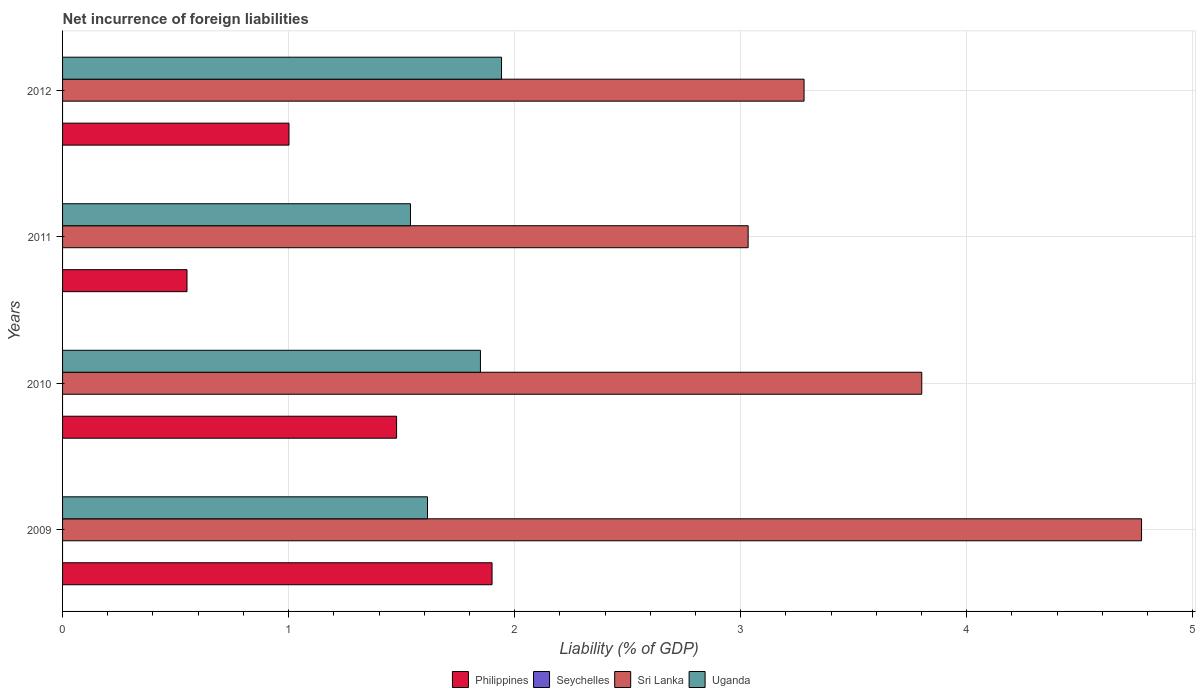How many groups of bars are there?
Offer a terse response. 4. Are the number of bars on each tick of the Y-axis equal?
Give a very brief answer. Yes. How many bars are there on the 4th tick from the top?
Provide a succinct answer. 3. How many bars are there on the 3rd tick from the bottom?
Give a very brief answer. 3. What is the net incurrence of foreign liabilities in Sri Lanka in 2009?
Your answer should be very brief. 4.77. Across all years, what is the maximum net incurrence of foreign liabilities in Philippines?
Provide a succinct answer. 1.9. In which year was the net incurrence of foreign liabilities in Uganda maximum?
Make the answer very short. 2012. What is the total net incurrence of foreign liabilities in Seychelles in the graph?
Your response must be concise. 0. What is the difference between the net incurrence of foreign liabilities in Philippines in 2009 and that in 2010?
Keep it short and to the point. 0.42. What is the difference between the net incurrence of foreign liabilities in Uganda in 2010 and the net incurrence of foreign liabilities in Seychelles in 2012?
Provide a succinct answer. 1.85. What is the average net incurrence of foreign liabilities in Philippines per year?
Make the answer very short. 1.23. In the year 2011, what is the difference between the net incurrence of foreign liabilities in Uganda and net incurrence of foreign liabilities in Philippines?
Offer a terse response. 0.99. What is the ratio of the net incurrence of foreign liabilities in Sri Lanka in 2009 to that in 2011?
Ensure brevity in your answer.  1.57. What is the difference between the highest and the second highest net incurrence of foreign liabilities in Philippines?
Your response must be concise. 0.42. What is the difference between the highest and the lowest net incurrence of foreign liabilities in Uganda?
Your response must be concise. 0.4. Is it the case that in every year, the sum of the net incurrence of foreign liabilities in Philippines and net incurrence of foreign liabilities in Uganda is greater than the sum of net incurrence of foreign liabilities in Seychelles and net incurrence of foreign liabilities in Sri Lanka?
Your answer should be compact. No. Are all the bars in the graph horizontal?
Provide a short and direct response. Yes. How many years are there in the graph?
Ensure brevity in your answer.  4. What is the difference between two consecutive major ticks on the X-axis?
Your answer should be very brief. 1. Does the graph contain grids?
Your answer should be compact. Yes. Where does the legend appear in the graph?
Provide a succinct answer. Bottom center. What is the title of the graph?
Your answer should be very brief. Net incurrence of foreign liabilities. What is the label or title of the X-axis?
Offer a terse response. Liability (% of GDP). What is the Liability (% of GDP) in Philippines in 2009?
Provide a succinct answer. 1.9. What is the Liability (% of GDP) of Sri Lanka in 2009?
Offer a very short reply. 4.77. What is the Liability (% of GDP) in Uganda in 2009?
Offer a very short reply. 1.61. What is the Liability (% of GDP) of Philippines in 2010?
Provide a short and direct response. 1.48. What is the Liability (% of GDP) of Sri Lanka in 2010?
Your answer should be very brief. 3.8. What is the Liability (% of GDP) in Uganda in 2010?
Offer a terse response. 1.85. What is the Liability (% of GDP) of Philippines in 2011?
Offer a very short reply. 0.55. What is the Liability (% of GDP) of Seychelles in 2011?
Offer a very short reply. 0. What is the Liability (% of GDP) of Sri Lanka in 2011?
Provide a succinct answer. 3.03. What is the Liability (% of GDP) in Uganda in 2011?
Provide a succinct answer. 1.54. What is the Liability (% of GDP) in Philippines in 2012?
Provide a succinct answer. 1. What is the Liability (% of GDP) of Sri Lanka in 2012?
Give a very brief answer. 3.28. What is the Liability (% of GDP) of Uganda in 2012?
Your answer should be compact. 1.94. Across all years, what is the maximum Liability (% of GDP) in Philippines?
Provide a short and direct response. 1.9. Across all years, what is the maximum Liability (% of GDP) in Sri Lanka?
Your answer should be very brief. 4.77. Across all years, what is the maximum Liability (% of GDP) in Uganda?
Provide a short and direct response. 1.94. Across all years, what is the minimum Liability (% of GDP) in Philippines?
Offer a terse response. 0.55. Across all years, what is the minimum Liability (% of GDP) of Sri Lanka?
Ensure brevity in your answer.  3.03. Across all years, what is the minimum Liability (% of GDP) of Uganda?
Ensure brevity in your answer.  1.54. What is the total Liability (% of GDP) of Philippines in the graph?
Your response must be concise. 4.93. What is the total Liability (% of GDP) of Seychelles in the graph?
Make the answer very short. 0. What is the total Liability (% of GDP) in Sri Lanka in the graph?
Your response must be concise. 14.89. What is the total Liability (% of GDP) in Uganda in the graph?
Provide a short and direct response. 6.94. What is the difference between the Liability (% of GDP) in Philippines in 2009 and that in 2010?
Offer a terse response. 0.42. What is the difference between the Liability (% of GDP) in Sri Lanka in 2009 and that in 2010?
Your answer should be very brief. 0.97. What is the difference between the Liability (% of GDP) in Uganda in 2009 and that in 2010?
Provide a succinct answer. -0.23. What is the difference between the Liability (% of GDP) in Philippines in 2009 and that in 2011?
Provide a short and direct response. 1.35. What is the difference between the Liability (% of GDP) of Sri Lanka in 2009 and that in 2011?
Your response must be concise. 1.74. What is the difference between the Liability (% of GDP) in Uganda in 2009 and that in 2011?
Provide a short and direct response. 0.08. What is the difference between the Liability (% of GDP) in Philippines in 2009 and that in 2012?
Ensure brevity in your answer.  0.9. What is the difference between the Liability (% of GDP) of Sri Lanka in 2009 and that in 2012?
Offer a terse response. 1.49. What is the difference between the Liability (% of GDP) in Uganda in 2009 and that in 2012?
Your response must be concise. -0.33. What is the difference between the Liability (% of GDP) in Philippines in 2010 and that in 2011?
Provide a succinct answer. 0.93. What is the difference between the Liability (% of GDP) of Sri Lanka in 2010 and that in 2011?
Provide a short and direct response. 0.77. What is the difference between the Liability (% of GDP) in Uganda in 2010 and that in 2011?
Your answer should be compact. 0.31. What is the difference between the Liability (% of GDP) in Philippines in 2010 and that in 2012?
Keep it short and to the point. 0.48. What is the difference between the Liability (% of GDP) in Sri Lanka in 2010 and that in 2012?
Your answer should be very brief. 0.52. What is the difference between the Liability (% of GDP) of Uganda in 2010 and that in 2012?
Keep it short and to the point. -0.09. What is the difference between the Liability (% of GDP) in Philippines in 2011 and that in 2012?
Make the answer very short. -0.45. What is the difference between the Liability (% of GDP) in Sri Lanka in 2011 and that in 2012?
Offer a terse response. -0.25. What is the difference between the Liability (% of GDP) in Uganda in 2011 and that in 2012?
Keep it short and to the point. -0.4. What is the difference between the Liability (% of GDP) in Philippines in 2009 and the Liability (% of GDP) in Sri Lanka in 2010?
Offer a very short reply. -1.9. What is the difference between the Liability (% of GDP) in Philippines in 2009 and the Liability (% of GDP) in Uganda in 2010?
Offer a terse response. 0.05. What is the difference between the Liability (% of GDP) in Sri Lanka in 2009 and the Liability (% of GDP) in Uganda in 2010?
Offer a very short reply. 2.92. What is the difference between the Liability (% of GDP) of Philippines in 2009 and the Liability (% of GDP) of Sri Lanka in 2011?
Your response must be concise. -1.13. What is the difference between the Liability (% of GDP) in Philippines in 2009 and the Liability (% of GDP) in Uganda in 2011?
Keep it short and to the point. 0.36. What is the difference between the Liability (% of GDP) in Sri Lanka in 2009 and the Liability (% of GDP) in Uganda in 2011?
Make the answer very short. 3.23. What is the difference between the Liability (% of GDP) of Philippines in 2009 and the Liability (% of GDP) of Sri Lanka in 2012?
Offer a terse response. -1.38. What is the difference between the Liability (% of GDP) of Philippines in 2009 and the Liability (% of GDP) of Uganda in 2012?
Offer a terse response. -0.04. What is the difference between the Liability (% of GDP) of Sri Lanka in 2009 and the Liability (% of GDP) of Uganda in 2012?
Give a very brief answer. 2.83. What is the difference between the Liability (% of GDP) in Philippines in 2010 and the Liability (% of GDP) in Sri Lanka in 2011?
Your answer should be very brief. -1.56. What is the difference between the Liability (% of GDP) in Philippines in 2010 and the Liability (% of GDP) in Uganda in 2011?
Your answer should be compact. -0.06. What is the difference between the Liability (% of GDP) of Sri Lanka in 2010 and the Liability (% of GDP) of Uganda in 2011?
Your answer should be compact. 2.26. What is the difference between the Liability (% of GDP) in Philippines in 2010 and the Liability (% of GDP) in Sri Lanka in 2012?
Ensure brevity in your answer.  -1.8. What is the difference between the Liability (% of GDP) in Philippines in 2010 and the Liability (% of GDP) in Uganda in 2012?
Provide a succinct answer. -0.46. What is the difference between the Liability (% of GDP) of Sri Lanka in 2010 and the Liability (% of GDP) of Uganda in 2012?
Provide a succinct answer. 1.86. What is the difference between the Liability (% of GDP) of Philippines in 2011 and the Liability (% of GDP) of Sri Lanka in 2012?
Your answer should be compact. -2.73. What is the difference between the Liability (% of GDP) in Philippines in 2011 and the Liability (% of GDP) in Uganda in 2012?
Give a very brief answer. -1.39. What is the difference between the Liability (% of GDP) in Sri Lanka in 2011 and the Liability (% of GDP) in Uganda in 2012?
Your answer should be compact. 1.09. What is the average Liability (% of GDP) of Philippines per year?
Give a very brief answer. 1.23. What is the average Liability (% of GDP) in Seychelles per year?
Offer a very short reply. 0. What is the average Liability (% of GDP) of Sri Lanka per year?
Make the answer very short. 3.72. What is the average Liability (% of GDP) in Uganda per year?
Keep it short and to the point. 1.74. In the year 2009, what is the difference between the Liability (% of GDP) in Philippines and Liability (% of GDP) in Sri Lanka?
Your response must be concise. -2.87. In the year 2009, what is the difference between the Liability (% of GDP) in Philippines and Liability (% of GDP) in Uganda?
Keep it short and to the point. 0.29. In the year 2009, what is the difference between the Liability (% of GDP) in Sri Lanka and Liability (% of GDP) in Uganda?
Provide a succinct answer. 3.16. In the year 2010, what is the difference between the Liability (% of GDP) of Philippines and Liability (% of GDP) of Sri Lanka?
Offer a terse response. -2.32. In the year 2010, what is the difference between the Liability (% of GDP) of Philippines and Liability (% of GDP) of Uganda?
Provide a succinct answer. -0.37. In the year 2010, what is the difference between the Liability (% of GDP) in Sri Lanka and Liability (% of GDP) in Uganda?
Keep it short and to the point. 1.95. In the year 2011, what is the difference between the Liability (% of GDP) of Philippines and Liability (% of GDP) of Sri Lanka?
Offer a very short reply. -2.48. In the year 2011, what is the difference between the Liability (% of GDP) of Philippines and Liability (% of GDP) of Uganda?
Make the answer very short. -0.99. In the year 2011, what is the difference between the Liability (% of GDP) in Sri Lanka and Liability (% of GDP) in Uganda?
Provide a short and direct response. 1.49. In the year 2012, what is the difference between the Liability (% of GDP) of Philippines and Liability (% of GDP) of Sri Lanka?
Give a very brief answer. -2.28. In the year 2012, what is the difference between the Liability (% of GDP) in Philippines and Liability (% of GDP) in Uganda?
Your answer should be very brief. -0.94. In the year 2012, what is the difference between the Liability (% of GDP) of Sri Lanka and Liability (% of GDP) of Uganda?
Offer a very short reply. 1.34. What is the ratio of the Liability (% of GDP) in Philippines in 2009 to that in 2010?
Give a very brief answer. 1.29. What is the ratio of the Liability (% of GDP) of Sri Lanka in 2009 to that in 2010?
Provide a short and direct response. 1.26. What is the ratio of the Liability (% of GDP) in Uganda in 2009 to that in 2010?
Your answer should be compact. 0.87. What is the ratio of the Liability (% of GDP) of Philippines in 2009 to that in 2011?
Offer a terse response. 3.45. What is the ratio of the Liability (% of GDP) of Sri Lanka in 2009 to that in 2011?
Your response must be concise. 1.57. What is the ratio of the Liability (% of GDP) of Uganda in 2009 to that in 2011?
Ensure brevity in your answer.  1.05. What is the ratio of the Liability (% of GDP) of Philippines in 2009 to that in 2012?
Your answer should be compact. 1.9. What is the ratio of the Liability (% of GDP) of Sri Lanka in 2009 to that in 2012?
Provide a short and direct response. 1.46. What is the ratio of the Liability (% of GDP) of Uganda in 2009 to that in 2012?
Make the answer very short. 0.83. What is the ratio of the Liability (% of GDP) in Philippines in 2010 to that in 2011?
Offer a terse response. 2.68. What is the ratio of the Liability (% of GDP) in Sri Lanka in 2010 to that in 2011?
Give a very brief answer. 1.25. What is the ratio of the Liability (% of GDP) of Uganda in 2010 to that in 2011?
Offer a very short reply. 1.2. What is the ratio of the Liability (% of GDP) in Philippines in 2010 to that in 2012?
Your answer should be very brief. 1.48. What is the ratio of the Liability (% of GDP) in Sri Lanka in 2010 to that in 2012?
Provide a succinct answer. 1.16. What is the ratio of the Liability (% of GDP) in Uganda in 2010 to that in 2012?
Your answer should be compact. 0.95. What is the ratio of the Liability (% of GDP) of Philippines in 2011 to that in 2012?
Provide a succinct answer. 0.55. What is the ratio of the Liability (% of GDP) in Sri Lanka in 2011 to that in 2012?
Your answer should be compact. 0.92. What is the ratio of the Liability (% of GDP) in Uganda in 2011 to that in 2012?
Your answer should be very brief. 0.79. What is the difference between the highest and the second highest Liability (% of GDP) of Philippines?
Your answer should be very brief. 0.42. What is the difference between the highest and the second highest Liability (% of GDP) in Sri Lanka?
Your response must be concise. 0.97. What is the difference between the highest and the second highest Liability (% of GDP) of Uganda?
Keep it short and to the point. 0.09. What is the difference between the highest and the lowest Liability (% of GDP) of Philippines?
Your answer should be very brief. 1.35. What is the difference between the highest and the lowest Liability (% of GDP) in Sri Lanka?
Keep it short and to the point. 1.74. What is the difference between the highest and the lowest Liability (% of GDP) in Uganda?
Keep it short and to the point. 0.4. 